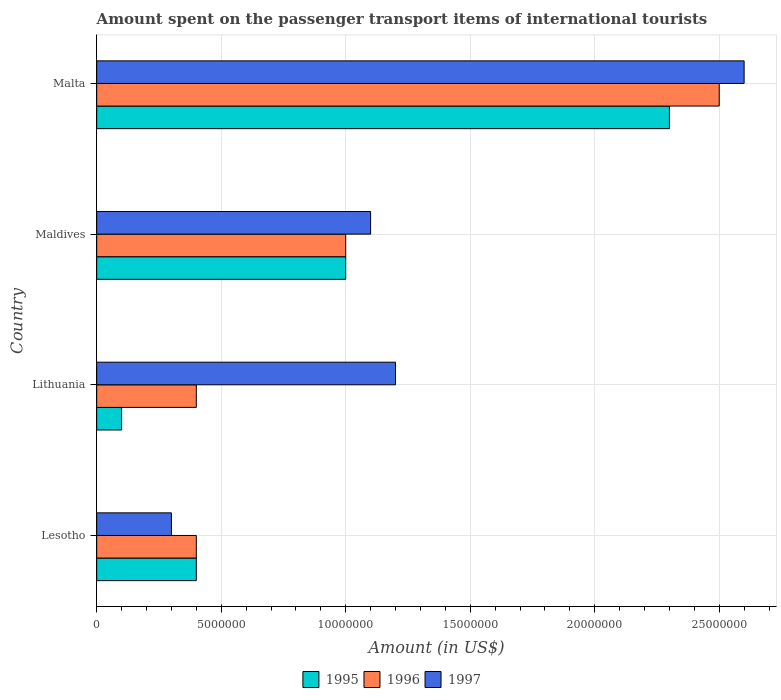How many groups of bars are there?
Ensure brevity in your answer.  4. Are the number of bars per tick equal to the number of legend labels?
Offer a terse response. Yes. Are the number of bars on each tick of the Y-axis equal?
Provide a short and direct response. Yes. What is the label of the 1st group of bars from the top?
Give a very brief answer. Malta. What is the amount spent on the passenger transport items of international tourists in 1995 in Malta?
Ensure brevity in your answer.  2.30e+07. Across all countries, what is the maximum amount spent on the passenger transport items of international tourists in 1996?
Offer a very short reply. 2.50e+07. Across all countries, what is the minimum amount spent on the passenger transport items of international tourists in 1996?
Make the answer very short. 4.00e+06. In which country was the amount spent on the passenger transport items of international tourists in 1996 maximum?
Offer a terse response. Malta. In which country was the amount spent on the passenger transport items of international tourists in 1997 minimum?
Your answer should be compact. Lesotho. What is the total amount spent on the passenger transport items of international tourists in 1995 in the graph?
Provide a short and direct response. 3.80e+07. What is the difference between the amount spent on the passenger transport items of international tourists in 1997 in Maldives and that in Malta?
Offer a terse response. -1.50e+07. What is the average amount spent on the passenger transport items of international tourists in 1995 per country?
Your answer should be compact. 9.50e+06. What is the difference between the amount spent on the passenger transport items of international tourists in 1995 and amount spent on the passenger transport items of international tourists in 1996 in Malta?
Offer a very short reply. -2.00e+06. What is the difference between the highest and the second highest amount spent on the passenger transport items of international tourists in 1996?
Provide a succinct answer. 1.50e+07. What is the difference between the highest and the lowest amount spent on the passenger transport items of international tourists in 1995?
Provide a succinct answer. 2.20e+07. Is the sum of the amount spent on the passenger transport items of international tourists in 1995 in Lithuania and Maldives greater than the maximum amount spent on the passenger transport items of international tourists in 1996 across all countries?
Your answer should be compact. No. How many bars are there?
Your answer should be compact. 12. Are all the bars in the graph horizontal?
Your answer should be compact. Yes. Are the values on the major ticks of X-axis written in scientific E-notation?
Offer a very short reply. No. Does the graph contain any zero values?
Offer a very short reply. No. Where does the legend appear in the graph?
Your response must be concise. Bottom center. What is the title of the graph?
Offer a terse response. Amount spent on the passenger transport items of international tourists. Does "2003" appear as one of the legend labels in the graph?
Provide a short and direct response. No. What is the Amount (in US$) in 1995 in Lesotho?
Ensure brevity in your answer.  4.00e+06. What is the Amount (in US$) in 1996 in Lesotho?
Offer a terse response. 4.00e+06. What is the Amount (in US$) in 1997 in Lesotho?
Keep it short and to the point. 3.00e+06. What is the Amount (in US$) of 1995 in Lithuania?
Offer a terse response. 1.00e+06. What is the Amount (in US$) of 1996 in Lithuania?
Your response must be concise. 4.00e+06. What is the Amount (in US$) of 1996 in Maldives?
Ensure brevity in your answer.  1.00e+07. What is the Amount (in US$) in 1997 in Maldives?
Offer a terse response. 1.10e+07. What is the Amount (in US$) of 1995 in Malta?
Make the answer very short. 2.30e+07. What is the Amount (in US$) of 1996 in Malta?
Your response must be concise. 2.50e+07. What is the Amount (in US$) of 1997 in Malta?
Offer a very short reply. 2.60e+07. Across all countries, what is the maximum Amount (in US$) of 1995?
Give a very brief answer. 2.30e+07. Across all countries, what is the maximum Amount (in US$) of 1996?
Ensure brevity in your answer.  2.50e+07. Across all countries, what is the maximum Amount (in US$) of 1997?
Your response must be concise. 2.60e+07. Across all countries, what is the minimum Amount (in US$) in 1995?
Ensure brevity in your answer.  1.00e+06. Across all countries, what is the minimum Amount (in US$) in 1997?
Your answer should be very brief. 3.00e+06. What is the total Amount (in US$) of 1995 in the graph?
Make the answer very short. 3.80e+07. What is the total Amount (in US$) in 1996 in the graph?
Your answer should be very brief. 4.30e+07. What is the total Amount (in US$) in 1997 in the graph?
Ensure brevity in your answer.  5.20e+07. What is the difference between the Amount (in US$) of 1997 in Lesotho and that in Lithuania?
Offer a terse response. -9.00e+06. What is the difference between the Amount (in US$) in 1995 in Lesotho and that in Maldives?
Your answer should be very brief. -6.00e+06. What is the difference between the Amount (in US$) in 1996 in Lesotho and that in Maldives?
Your answer should be compact. -6.00e+06. What is the difference between the Amount (in US$) in 1997 in Lesotho and that in Maldives?
Your answer should be compact. -8.00e+06. What is the difference between the Amount (in US$) in 1995 in Lesotho and that in Malta?
Make the answer very short. -1.90e+07. What is the difference between the Amount (in US$) of 1996 in Lesotho and that in Malta?
Make the answer very short. -2.10e+07. What is the difference between the Amount (in US$) in 1997 in Lesotho and that in Malta?
Keep it short and to the point. -2.30e+07. What is the difference between the Amount (in US$) of 1995 in Lithuania and that in Maldives?
Ensure brevity in your answer.  -9.00e+06. What is the difference between the Amount (in US$) of 1996 in Lithuania and that in Maldives?
Your answer should be compact. -6.00e+06. What is the difference between the Amount (in US$) of 1997 in Lithuania and that in Maldives?
Your answer should be compact. 1.00e+06. What is the difference between the Amount (in US$) of 1995 in Lithuania and that in Malta?
Give a very brief answer. -2.20e+07. What is the difference between the Amount (in US$) of 1996 in Lithuania and that in Malta?
Your answer should be compact. -2.10e+07. What is the difference between the Amount (in US$) of 1997 in Lithuania and that in Malta?
Keep it short and to the point. -1.40e+07. What is the difference between the Amount (in US$) in 1995 in Maldives and that in Malta?
Keep it short and to the point. -1.30e+07. What is the difference between the Amount (in US$) in 1996 in Maldives and that in Malta?
Give a very brief answer. -1.50e+07. What is the difference between the Amount (in US$) in 1997 in Maldives and that in Malta?
Ensure brevity in your answer.  -1.50e+07. What is the difference between the Amount (in US$) in 1995 in Lesotho and the Amount (in US$) in 1996 in Lithuania?
Give a very brief answer. 0. What is the difference between the Amount (in US$) in 1995 in Lesotho and the Amount (in US$) in 1997 in Lithuania?
Provide a short and direct response. -8.00e+06. What is the difference between the Amount (in US$) in 1996 in Lesotho and the Amount (in US$) in 1997 in Lithuania?
Offer a terse response. -8.00e+06. What is the difference between the Amount (in US$) of 1995 in Lesotho and the Amount (in US$) of 1996 in Maldives?
Provide a short and direct response. -6.00e+06. What is the difference between the Amount (in US$) of 1995 in Lesotho and the Amount (in US$) of 1997 in Maldives?
Your response must be concise. -7.00e+06. What is the difference between the Amount (in US$) of 1996 in Lesotho and the Amount (in US$) of 1997 in Maldives?
Your response must be concise. -7.00e+06. What is the difference between the Amount (in US$) in 1995 in Lesotho and the Amount (in US$) in 1996 in Malta?
Offer a very short reply. -2.10e+07. What is the difference between the Amount (in US$) of 1995 in Lesotho and the Amount (in US$) of 1997 in Malta?
Ensure brevity in your answer.  -2.20e+07. What is the difference between the Amount (in US$) of 1996 in Lesotho and the Amount (in US$) of 1997 in Malta?
Ensure brevity in your answer.  -2.20e+07. What is the difference between the Amount (in US$) of 1995 in Lithuania and the Amount (in US$) of 1996 in Maldives?
Provide a succinct answer. -9.00e+06. What is the difference between the Amount (in US$) in 1995 in Lithuania and the Amount (in US$) in 1997 in Maldives?
Make the answer very short. -1.00e+07. What is the difference between the Amount (in US$) of 1996 in Lithuania and the Amount (in US$) of 1997 in Maldives?
Offer a terse response. -7.00e+06. What is the difference between the Amount (in US$) in 1995 in Lithuania and the Amount (in US$) in 1996 in Malta?
Make the answer very short. -2.40e+07. What is the difference between the Amount (in US$) of 1995 in Lithuania and the Amount (in US$) of 1997 in Malta?
Ensure brevity in your answer.  -2.50e+07. What is the difference between the Amount (in US$) in 1996 in Lithuania and the Amount (in US$) in 1997 in Malta?
Offer a very short reply. -2.20e+07. What is the difference between the Amount (in US$) of 1995 in Maldives and the Amount (in US$) of 1996 in Malta?
Your response must be concise. -1.50e+07. What is the difference between the Amount (in US$) of 1995 in Maldives and the Amount (in US$) of 1997 in Malta?
Your answer should be very brief. -1.60e+07. What is the difference between the Amount (in US$) in 1996 in Maldives and the Amount (in US$) in 1997 in Malta?
Ensure brevity in your answer.  -1.60e+07. What is the average Amount (in US$) in 1995 per country?
Give a very brief answer. 9.50e+06. What is the average Amount (in US$) of 1996 per country?
Ensure brevity in your answer.  1.08e+07. What is the average Amount (in US$) in 1997 per country?
Ensure brevity in your answer.  1.30e+07. What is the difference between the Amount (in US$) in 1995 and Amount (in US$) in 1997 in Lesotho?
Your answer should be very brief. 1.00e+06. What is the difference between the Amount (in US$) in 1995 and Amount (in US$) in 1997 in Lithuania?
Offer a terse response. -1.10e+07. What is the difference between the Amount (in US$) of 1996 and Amount (in US$) of 1997 in Lithuania?
Offer a terse response. -8.00e+06. What is the difference between the Amount (in US$) in 1996 and Amount (in US$) in 1997 in Maldives?
Offer a terse response. -1.00e+06. What is the difference between the Amount (in US$) of 1995 and Amount (in US$) of 1997 in Malta?
Offer a terse response. -3.00e+06. What is the difference between the Amount (in US$) in 1996 and Amount (in US$) in 1997 in Malta?
Keep it short and to the point. -1.00e+06. What is the ratio of the Amount (in US$) of 1996 in Lesotho to that in Lithuania?
Make the answer very short. 1. What is the ratio of the Amount (in US$) in 1997 in Lesotho to that in Lithuania?
Your answer should be very brief. 0.25. What is the ratio of the Amount (in US$) of 1995 in Lesotho to that in Maldives?
Your answer should be compact. 0.4. What is the ratio of the Amount (in US$) in 1997 in Lesotho to that in Maldives?
Make the answer very short. 0.27. What is the ratio of the Amount (in US$) of 1995 in Lesotho to that in Malta?
Your answer should be compact. 0.17. What is the ratio of the Amount (in US$) in 1996 in Lesotho to that in Malta?
Your answer should be compact. 0.16. What is the ratio of the Amount (in US$) of 1997 in Lesotho to that in Malta?
Ensure brevity in your answer.  0.12. What is the ratio of the Amount (in US$) of 1997 in Lithuania to that in Maldives?
Your answer should be very brief. 1.09. What is the ratio of the Amount (in US$) in 1995 in Lithuania to that in Malta?
Keep it short and to the point. 0.04. What is the ratio of the Amount (in US$) in 1996 in Lithuania to that in Malta?
Your response must be concise. 0.16. What is the ratio of the Amount (in US$) in 1997 in Lithuania to that in Malta?
Your response must be concise. 0.46. What is the ratio of the Amount (in US$) in 1995 in Maldives to that in Malta?
Keep it short and to the point. 0.43. What is the ratio of the Amount (in US$) of 1997 in Maldives to that in Malta?
Your answer should be very brief. 0.42. What is the difference between the highest and the second highest Amount (in US$) of 1995?
Provide a short and direct response. 1.30e+07. What is the difference between the highest and the second highest Amount (in US$) in 1996?
Offer a terse response. 1.50e+07. What is the difference between the highest and the second highest Amount (in US$) of 1997?
Provide a succinct answer. 1.40e+07. What is the difference between the highest and the lowest Amount (in US$) in 1995?
Offer a very short reply. 2.20e+07. What is the difference between the highest and the lowest Amount (in US$) of 1996?
Keep it short and to the point. 2.10e+07. What is the difference between the highest and the lowest Amount (in US$) of 1997?
Your answer should be very brief. 2.30e+07. 